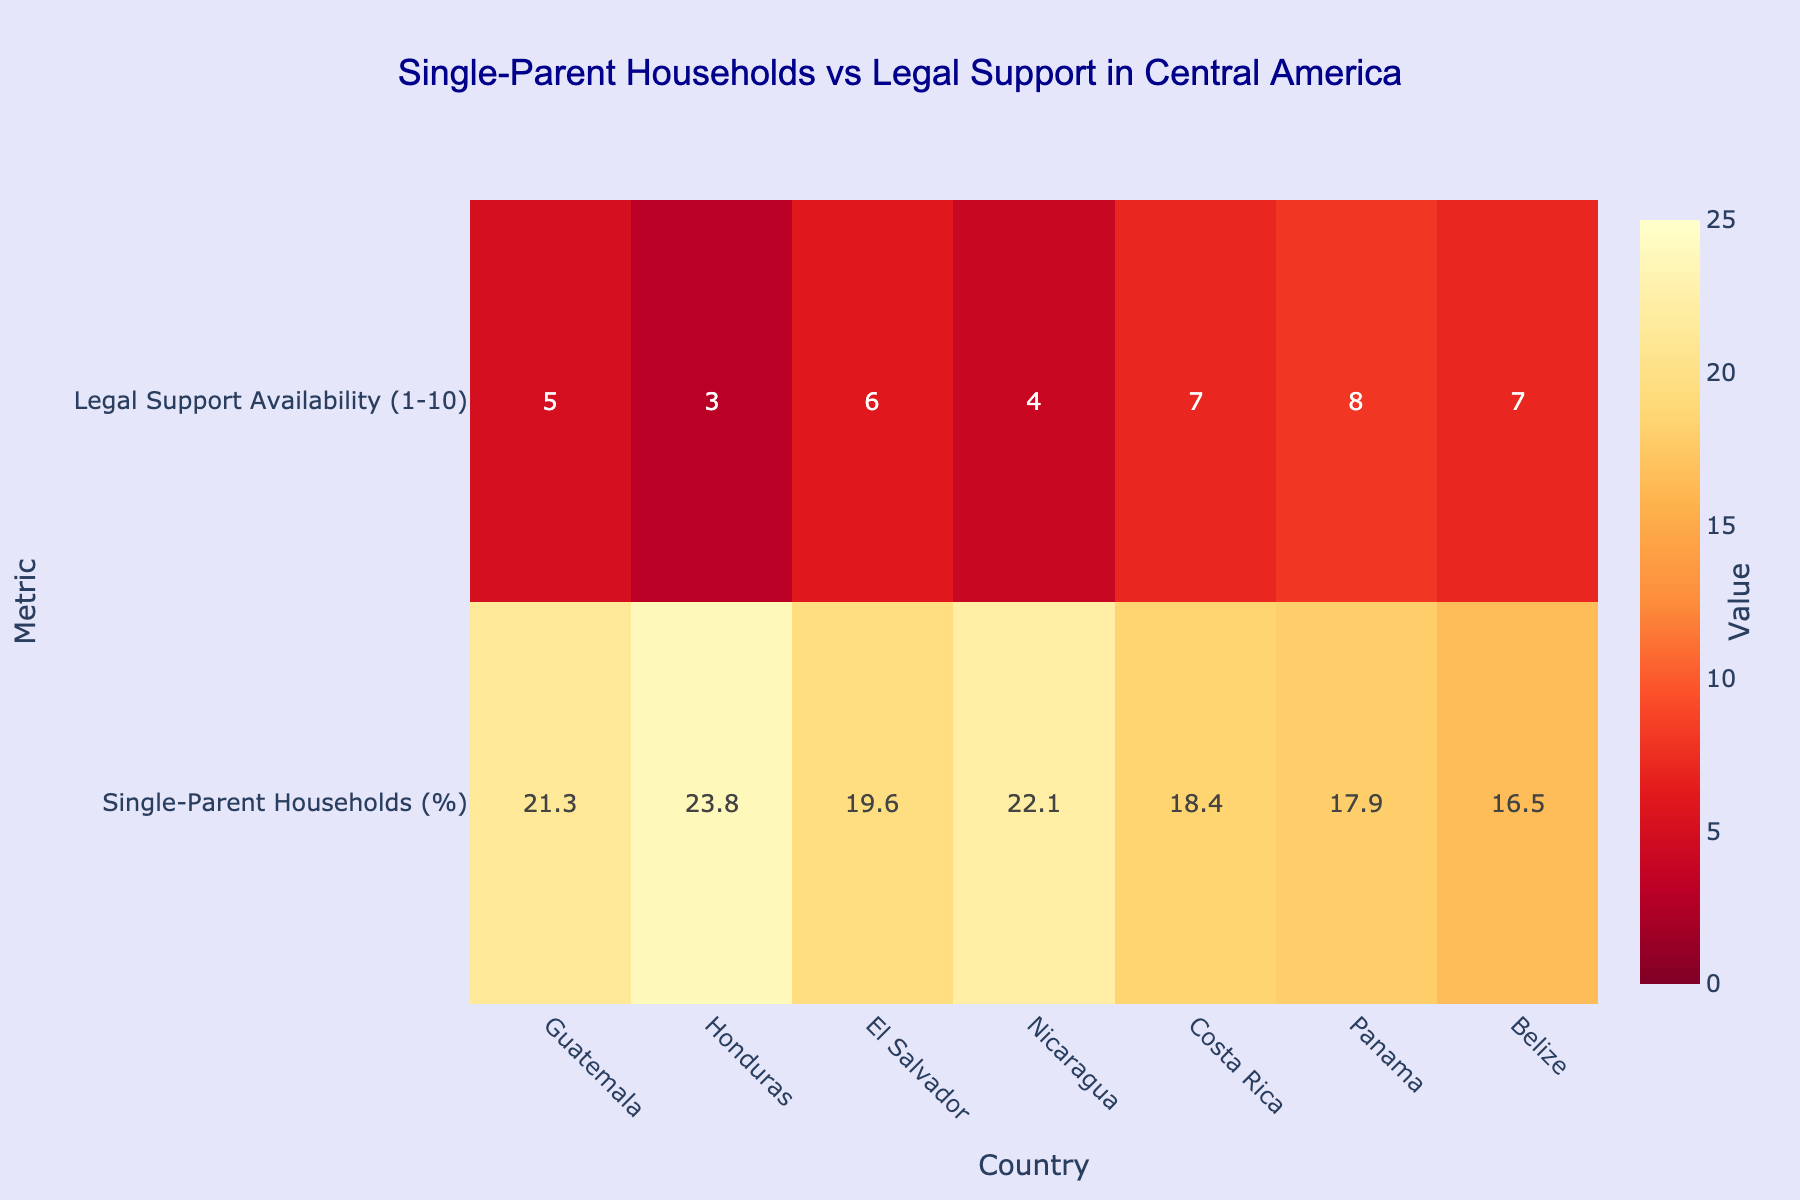What's the title of the heatmap? The title of the heatmap is located at the top center of the figure. It is usually written in a distinct font size and color for visibility.
Answer: Single-Parent Households vs Legal Support in Central America Which country has the highest percentage of single-parent households? Observing the data rows in the heatmap, identify the country with the highest value under the 'Single-Parent Households (%)' metric.
Answer: Honduras What is the legal support availability score for Panama? Look at the cell corresponding to Panama in the 'Legal Support Availability' row in the heatmap.
Answer: 8 Which country has the least legal support availability? Find the minimum value in the 'Legal Support Availability (1-10)' row and note the corresponding country.
Answer: Honduras What is the difference between the highest and lowest percentage of single-parent households? Identify the maximum and minimum values in the 'Single-Parent Households (%)' row and subtract the minimum from the maximum.
Answer: 23.8% - 16.5% = 7.3% Which country shows a relatively balanced scenario between single-parent households' prevalence and legal support availability? Look for a country where both metrics have moderate values, neither too high nor too low, indicating balance.
Answer: Nicaragua What is the average legal support availability across all countries? Sum the values in the 'Legal Support Availability (1-10)' row and divide by the total number of countries (7).
Answer: (5+3+6+4+7+8+7) / 7 = 40/7 ≈ 5.7 How do Belize and Costa Rica compare in terms of single-parent households' prevalence? Compare the values of 'Single-Parent Households (%)' for Belize and Costa Rica observed in the heatmap.
Answer: Belize: 16.5%, Costa Rica: 18.4% Which country has the lowest percentage of single-parent households and what is its legal support availability score? Identify the country with the smallest value in the 'Single-Parent Households (%)' row and find its corresponding value in the 'Legal Support Availability' row.
Answer: Belize, 7 